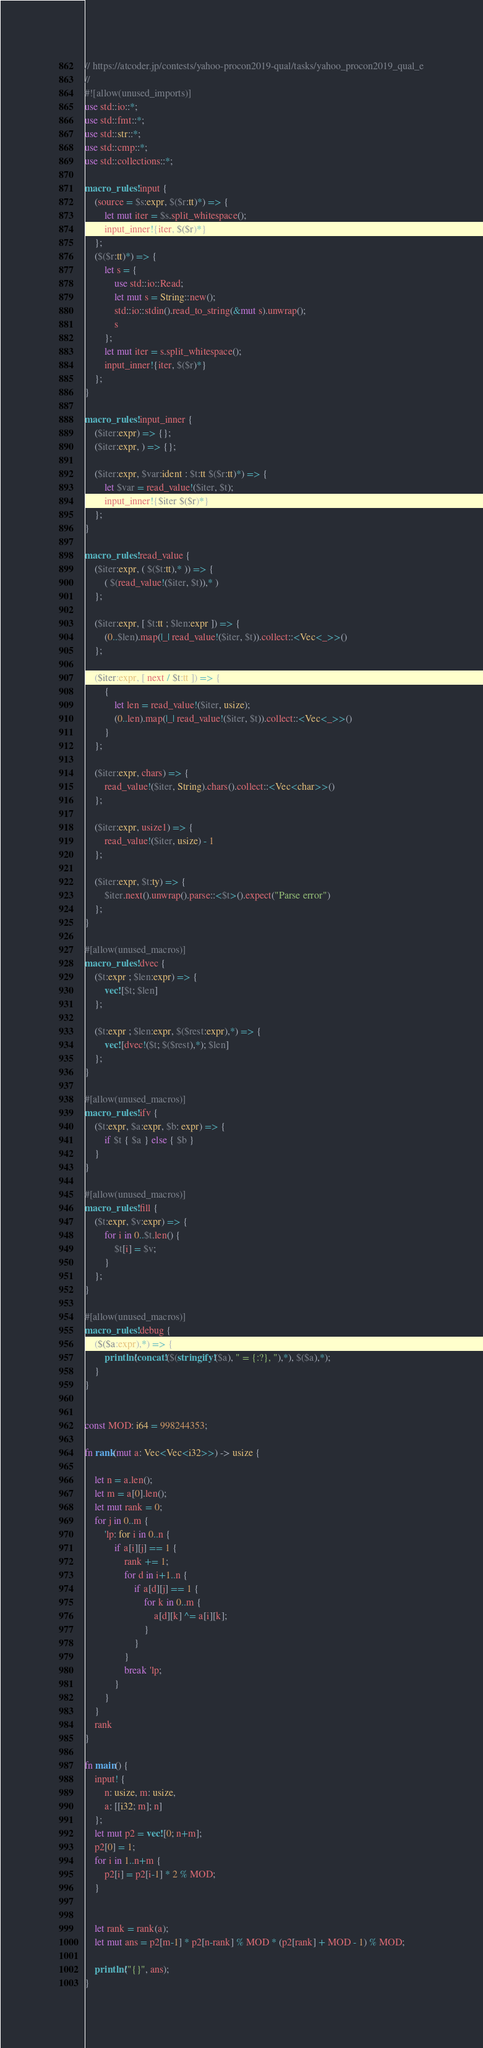Convert code to text. <code><loc_0><loc_0><loc_500><loc_500><_Rust_>// https://atcoder.jp/contests/yahoo-procon2019-qual/tasks/yahoo_procon2019_qual_e
//
#![allow(unused_imports)]
use std::io::*;
use std::fmt::*;
use std::str::*;
use std::cmp::*;
use std::collections::*;

macro_rules! input {
    (source = $s:expr, $($r:tt)*) => {
        let mut iter = $s.split_whitespace();
        input_inner!{iter, $($r)*}
    };
    ($($r:tt)*) => {
        let s = {
            use std::io::Read;
            let mut s = String::new();
            std::io::stdin().read_to_string(&mut s).unwrap();
            s
        };
        let mut iter = s.split_whitespace();
        input_inner!{iter, $($r)*}
    };
}

macro_rules! input_inner {
    ($iter:expr) => {};
    ($iter:expr, ) => {};

    ($iter:expr, $var:ident : $t:tt $($r:tt)*) => {
        let $var = read_value!($iter, $t);
        input_inner!{$iter $($r)*}
    };
}

macro_rules! read_value {
    ($iter:expr, ( $($t:tt),* )) => {
        ( $(read_value!($iter, $t)),* )
    };

    ($iter:expr, [ $t:tt ; $len:expr ]) => {
        (0..$len).map(|_| read_value!($iter, $t)).collect::<Vec<_>>()
    };

    ($iter:expr, [ next / $t:tt ]) => {
        {
            let len = read_value!($iter, usize);
            (0..len).map(|_| read_value!($iter, $t)).collect::<Vec<_>>()
        }
    };

    ($iter:expr, chars) => {
        read_value!($iter, String).chars().collect::<Vec<char>>()
    };

    ($iter:expr, usize1) => {
        read_value!($iter, usize) - 1
    };

    ($iter:expr, $t:ty) => {
        $iter.next().unwrap().parse::<$t>().expect("Parse error")
    };
}

#[allow(unused_macros)]
macro_rules! dvec {
    ($t:expr ; $len:expr) => {
        vec![$t; $len]
    };

    ($t:expr ; $len:expr, $($rest:expr),*) => {
        vec![dvec!($t; $($rest),*); $len]
    };
}

#[allow(unused_macros)]
macro_rules! ifv {
    ($t:expr, $a:expr, $b: expr) => {
        if $t { $a } else { $b }
    }
}

#[allow(unused_macros)]
macro_rules! fill {
    ($t:expr, $v:expr) => {
        for i in 0..$t.len() {
            $t[i] = $v;
        }
    };
}

#[allow(unused_macros)]
macro_rules! debug {
    ($($a:expr),*) => {
        println!(concat!($(stringify!($a), " = {:?}, "),*), $($a),*);
    }
}


const MOD: i64 = 998244353;

fn rank(mut a: Vec<Vec<i32>>) -> usize {

    let n = a.len();
    let m = a[0].len();
    let mut rank = 0;
    for j in 0..m {
        'lp: for i in 0..n {
            if a[i][j] == 1 {
                rank += 1;
                for d in i+1..n {
                    if a[d][j] == 1 {
                        for k in 0..m {
                            a[d][k] ^= a[i][k];
                        }
                    }
                }
                break 'lp;
            }
        }
    }
    rank
}

fn main() {
    input! {
        n: usize, m: usize,
        a: [[i32; m]; n]
    };
    let mut p2 = vec![0; n+m];
    p2[0] = 1;
    for i in 1..n+m {
        p2[i] = p2[i-1] * 2 % MOD;
    }


    let rank = rank(a);
    let mut ans = p2[m-1] * p2[n-rank] % MOD * (p2[rank] + MOD - 1) % MOD;

    println!("{}", ans);
}
</code> 